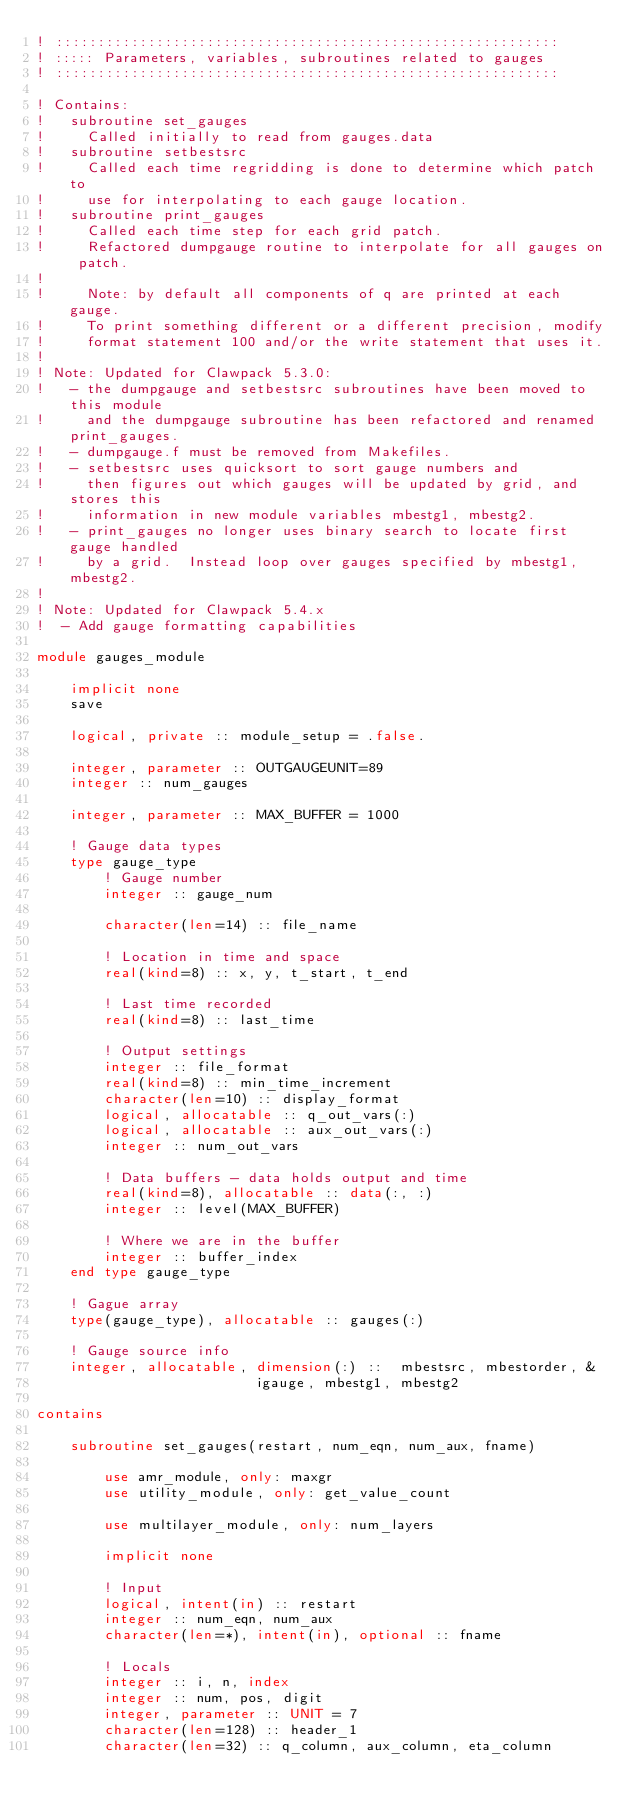Convert code to text. <code><loc_0><loc_0><loc_500><loc_500><_FORTRAN_>! ::::::::::::::::::::::::::::::::::::::::::::::::::::::::::::
! ::::: Parameters, variables, subroutines related to gauges
! ::::::::::::::::::::::::::::::::::::::::::::::::::::::::::::

! Contains:
!   subroutine set_gauges
!     Called initially to read from gauges.data
!   subroutine setbestsrc
!     Called each time regridding is done to determine which patch to 
!     use for interpolating to each gauge location.
!   subroutine print_gauges
!     Called each time step for each grid patch.
!     Refactored dumpgauge routine to interpolate for all gauges on patch.
!
!     Note: by default all components of q are printed at each gauge.
!     To print something different or a different precision, modify 
!     format statement 100 and/or the write statement that uses it.
!   
! Note: Updated for Clawpack 5.3.0:
!   - the dumpgauge and setbestsrc subroutines have been moved to this module 
!     and the dumpgauge subroutine has been refactored and renamed print_gauges.
!   - dumpgauge.f must be removed from Makefiles.
!   - setbestsrc uses quicksort to sort gauge numbers and
!     then figures out which gauges will be updated by grid, and stores this
!     information in new module variables mbestg1, mbestg2.
!   - print_gauges no longer uses binary search to locate first gauge handled
!     by a grid.  Instead loop over gauges specified by mbestg1, mbestg2.
!
! Note: Updated for Clawpack 5.4.x
!  - Add gauge formatting capabilities

module gauges_module

    implicit none
    save

    logical, private :: module_setup = .false.

    integer, parameter :: OUTGAUGEUNIT=89
    integer :: num_gauges

    integer, parameter :: MAX_BUFFER = 1000

    ! Gauge data types
    type gauge_type
        ! Gauge number
        integer :: gauge_num

        character(len=14) :: file_name

        ! Location in time and space
        real(kind=8) :: x, y, t_start, t_end

        ! Last time recorded
        real(kind=8) :: last_time

        ! Output settings
        integer :: file_format
        real(kind=8) :: min_time_increment
        character(len=10) :: display_format
        logical, allocatable :: q_out_vars(:)
        logical, allocatable :: aux_out_vars(:)
        integer :: num_out_vars

        ! Data buffers - data holds output and time
        real(kind=8), allocatable :: data(:, :)
        integer :: level(MAX_BUFFER)

        ! Where we are in the buffer
        integer :: buffer_index
    end type gauge_type

    ! Gague array
    type(gauge_type), allocatable :: gauges(:)

    ! Gauge source info
    integer, allocatable, dimension(:) ::  mbestsrc, mbestorder, &
                          igauge, mbestg1, mbestg2

contains

    subroutine set_gauges(restart, num_eqn, num_aux, fname)

        use amr_module, only: maxgr
        use utility_module, only: get_value_count

        use multilayer_module, only: num_layers

        implicit none

        ! Input
        logical, intent(in) :: restart
        integer :: num_eqn, num_aux
        character(len=*), intent(in), optional :: fname

        ! Locals
        integer :: i, n, index
        integer :: num, pos, digit
        integer, parameter :: UNIT = 7
        character(len=128) :: header_1
        character(len=32) :: q_column, aux_column, eta_column
</code> 